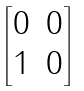Convert formula to latex. <formula><loc_0><loc_0><loc_500><loc_500>\begin{bmatrix} 0 & 0 \\ 1 & 0 \end{bmatrix}</formula> 